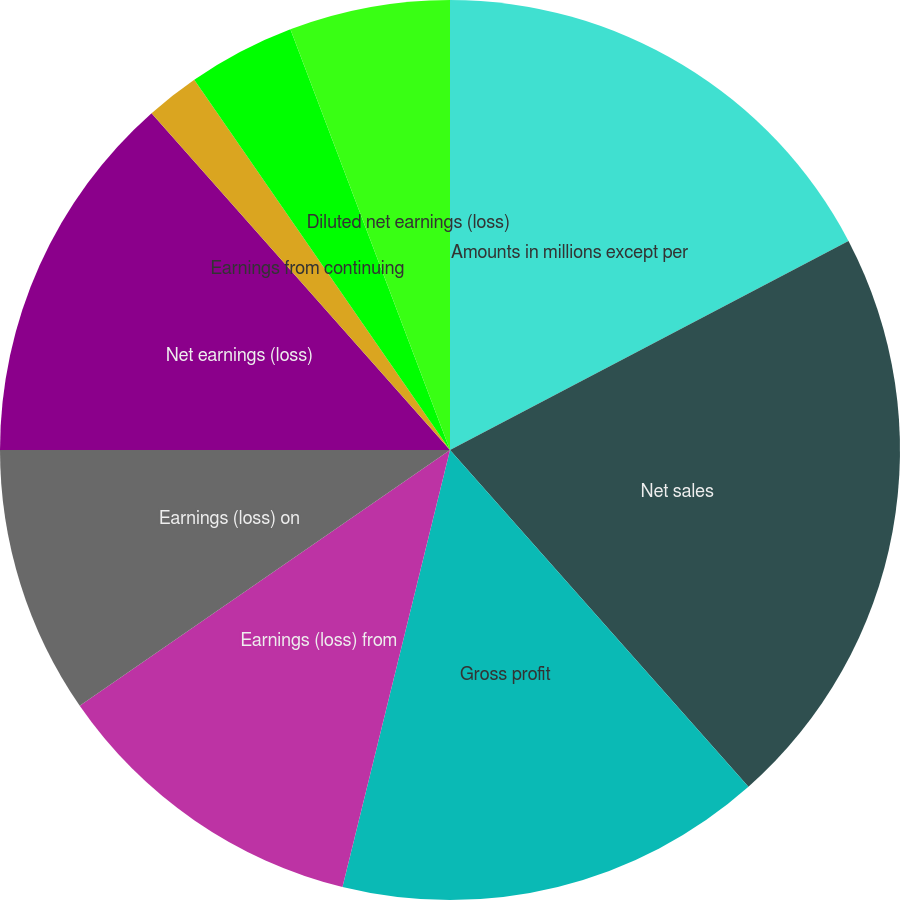Convert chart. <chart><loc_0><loc_0><loc_500><loc_500><pie_chart><fcel>Amounts in millions except per<fcel>Net sales<fcel>Gross profit<fcel>Earnings (loss) from<fcel>Earnings (loss) on<fcel>Net earnings (loss)<fcel>Earnings from continuing<fcel>Discontinued operations<fcel>Basic net earnings (loss) per<fcel>Diluted net earnings (loss)<nl><fcel>17.31%<fcel>21.15%<fcel>15.38%<fcel>11.54%<fcel>9.62%<fcel>13.46%<fcel>1.92%<fcel>0.0%<fcel>3.85%<fcel>5.77%<nl></chart> 